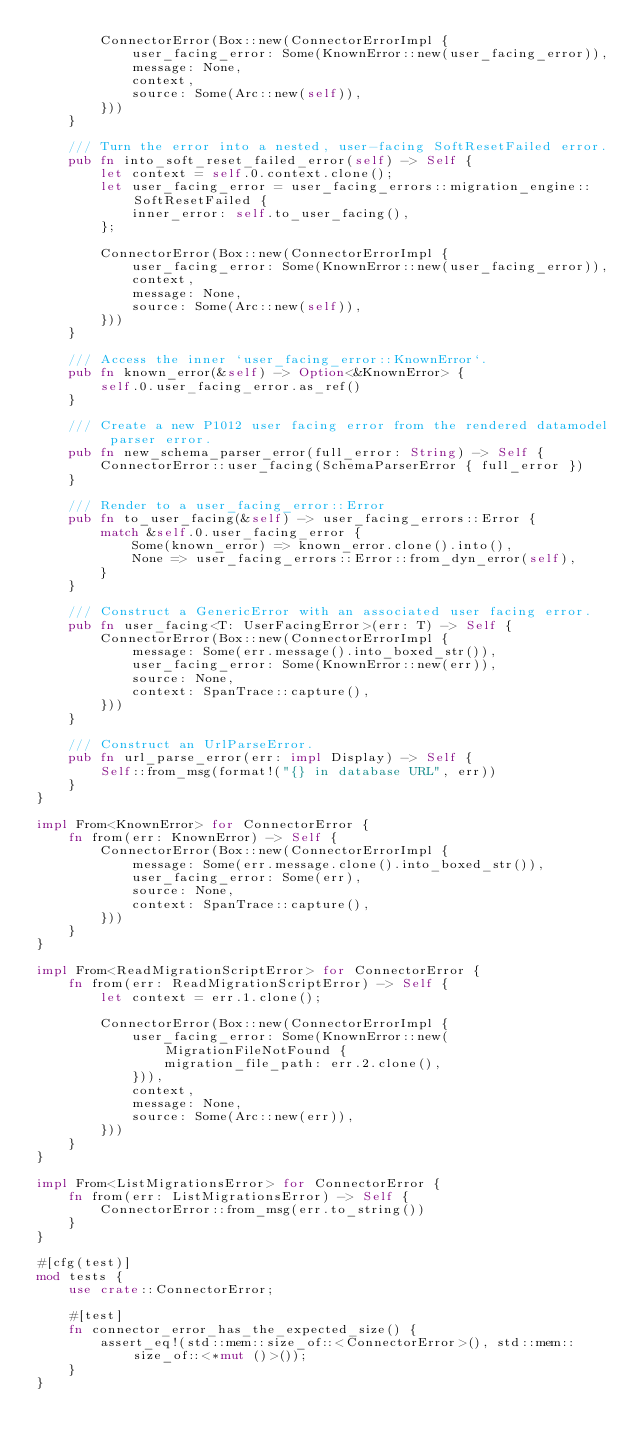<code> <loc_0><loc_0><loc_500><loc_500><_Rust_>        ConnectorError(Box::new(ConnectorErrorImpl {
            user_facing_error: Some(KnownError::new(user_facing_error)),
            message: None,
            context,
            source: Some(Arc::new(self)),
        }))
    }

    /// Turn the error into a nested, user-facing SoftResetFailed error.
    pub fn into_soft_reset_failed_error(self) -> Self {
        let context = self.0.context.clone();
        let user_facing_error = user_facing_errors::migration_engine::SoftResetFailed {
            inner_error: self.to_user_facing(),
        };

        ConnectorError(Box::new(ConnectorErrorImpl {
            user_facing_error: Some(KnownError::new(user_facing_error)),
            context,
            message: None,
            source: Some(Arc::new(self)),
        }))
    }

    /// Access the inner `user_facing_error::KnownError`.
    pub fn known_error(&self) -> Option<&KnownError> {
        self.0.user_facing_error.as_ref()
    }

    /// Create a new P1012 user facing error from the rendered datamodel parser error.
    pub fn new_schema_parser_error(full_error: String) -> Self {
        ConnectorError::user_facing(SchemaParserError { full_error })
    }

    /// Render to a user_facing_error::Error
    pub fn to_user_facing(&self) -> user_facing_errors::Error {
        match &self.0.user_facing_error {
            Some(known_error) => known_error.clone().into(),
            None => user_facing_errors::Error::from_dyn_error(self),
        }
    }

    /// Construct a GenericError with an associated user facing error.
    pub fn user_facing<T: UserFacingError>(err: T) -> Self {
        ConnectorError(Box::new(ConnectorErrorImpl {
            message: Some(err.message().into_boxed_str()),
            user_facing_error: Some(KnownError::new(err)),
            source: None,
            context: SpanTrace::capture(),
        }))
    }

    /// Construct an UrlParseError.
    pub fn url_parse_error(err: impl Display) -> Self {
        Self::from_msg(format!("{} in database URL", err))
    }
}

impl From<KnownError> for ConnectorError {
    fn from(err: KnownError) -> Self {
        ConnectorError(Box::new(ConnectorErrorImpl {
            message: Some(err.message.clone().into_boxed_str()),
            user_facing_error: Some(err),
            source: None,
            context: SpanTrace::capture(),
        }))
    }
}

impl From<ReadMigrationScriptError> for ConnectorError {
    fn from(err: ReadMigrationScriptError) -> Self {
        let context = err.1.clone();

        ConnectorError(Box::new(ConnectorErrorImpl {
            user_facing_error: Some(KnownError::new(MigrationFileNotFound {
                migration_file_path: err.2.clone(),
            })),
            context,
            message: None,
            source: Some(Arc::new(err)),
        }))
    }
}

impl From<ListMigrationsError> for ConnectorError {
    fn from(err: ListMigrationsError) -> Self {
        ConnectorError::from_msg(err.to_string())
    }
}

#[cfg(test)]
mod tests {
    use crate::ConnectorError;

    #[test]
    fn connector_error_has_the_expected_size() {
        assert_eq!(std::mem::size_of::<ConnectorError>(), std::mem::size_of::<*mut ()>());
    }
}
</code> 